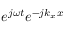Convert formula to latex. <formula><loc_0><loc_0><loc_500><loc_500>{ e ^ { j \omega t } } { e ^ { - j { k _ { x } } x } }</formula> 